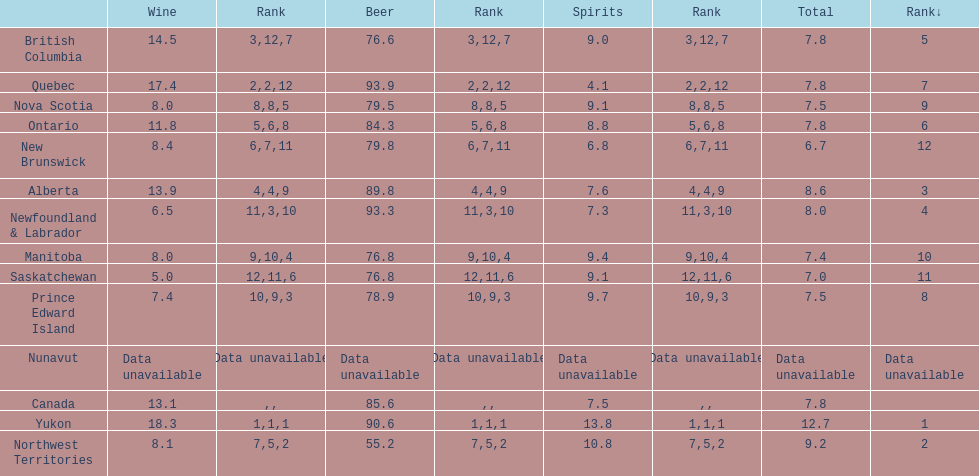Which province consumes the least amount of spirits? Quebec. 